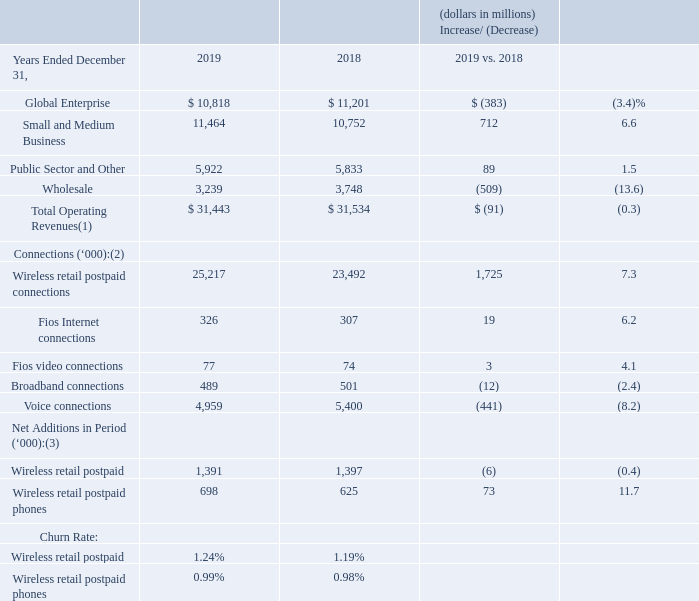Operating Revenues and Selected Operating Statistics
(1) Service and other revenues included in our Business segment amounted to approximately $27.9 billion and $28.1 billion for the years ended December 31, 2019 and 2018, respectively. Wireless equipment revenues included in our Business segment amounted to approximately $3.5 billion and $3.4 billion for the years ended December 31, 2019 and 2018, respectively. (2) As of end of period (3) Includes certain adjustments
Business revenues decreased $91 million, or 0.3%, during 2019 compared to 2018, primarily due to decreases in Global Enterprise and Wholesale revenues, partially offset by increases in Small and Medium Business and Public Sector and Other revenues.
Global Enterprise Global Enterprise offers services to large businesses, which are identified based on their size and volume of business with Verizon, as well as non-U.S. public sector customers. Global Enterprise revenues decreased $383 million, or 3.4%, during 2019 compared to 2018, primarily due to declines in traditional data and voice communication services as a result of competitive price pressures. These revenue decreases were partially offset by increases in wireless service revenue.
Small and Medium Business Small and Medium Business offers wireless services and equipment, tailored voice and networking products, Fios services, IP networking, advanced voice solutions, security and managed information technology services to our U.S.-based customers that do not meet the requirements to be categorized as Global Enterprise.
Small and Medium Business revenues increased $712 million, or 6.6%, during 2019 compared to 2018, primarily due to an increase in wireless postpaid service revenue of 11.7% as a result of increases in the amount of wireless retail postpaid connections.
These increases were further driven by increased wireless equipment revenue resulting from a shift to higher priced units in the mix of wireless devices sold and increases in the number of wireless devices sold, increased revenue related to our wireless device protection package, as well as increased revenue related to Fios services. These revenue increases were partially offset by revenue declines related to the loss of voice and DSL service connections.
Small and Medium Business Fios revenues totaled $915 million and increased $110 million, or 13.7%, during 2019 compared to 2018, reflecting the increase in total connections, as well as increased demand for higher broadband speeds.
Public Sector and Other Public Sector and Other offers wireless products and services as well as wireline connectivity and managed solutions to U.S. federal, state and local governments and educational institutions. These services include the business services and connectivity similar to the products and services offered by Global Enterprise, in each case, with features and pricing designed to address the needs of governments and educational institutions.
Public Sector and Other revenues increased $89 million, or 1.5%, during 2019 compared to 2018, driven by increases in networking and wireless postpaid service revenue as a result of an increase in wireless retail postpaid connections.
Wholesale Wholesale offers wireline communications services including data, voice, local dial tone and broadband services primarily to local, long distance, and wireless carriers that use our facilities to provide services to their customers. Wholesale revenues decreased $509 million, or 13.6%, during 2019 compared to 2018, primarily due to declines in core data and traditional voice services resulting from the effect of technology substitution and continuing contraction of market rates due to competition.
How much did Service and other revenues amounted for   years ended December 31, 2019 and 2018 respectively? $27.9 billion, $28.1 billion. How much did Wireless equipment revenues amounted for   years ended December 31, 2019 and 2018 respectively? $3.5 billion, $3.4 billion. Why did Business revenues decrease during 2019? Due to decreases in global enterprise and wholesale revenues, partially offset by increases in small and medium business and public sector and other revenues. What is the change in Global Enterprise value from 2018 to 2019?
Answer scale should be: million. 10,818-11,201
Answer: -383. What is the change in Small and Medium Business value from 2018 to 2019?
Answer scale should be: million. 11,464-10,752
Answer: 712. What is the change in Wholesale value from 2018 to 2019?
Answer scale should be: million. 3,239-3,748
Answer: -509. 